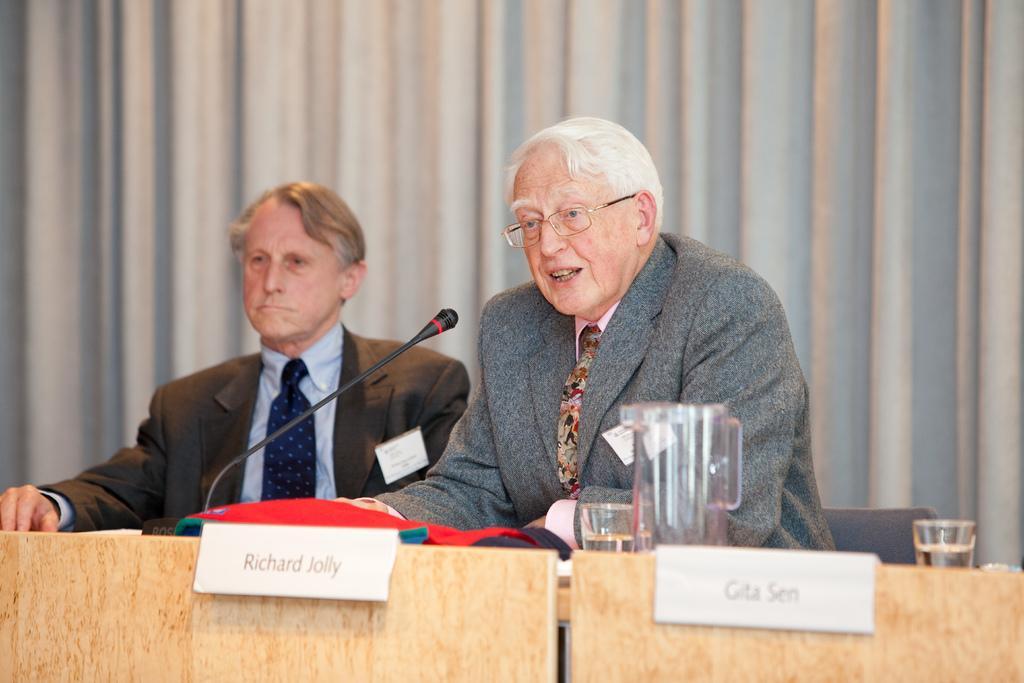Describe this image in one or two sentences. This picture shows few people seated on the chairs and we see a man speaking with the help of a microphone on the table and we see a water Jug and couple of glasses and name boards to the tables and we see curtains on the back. 